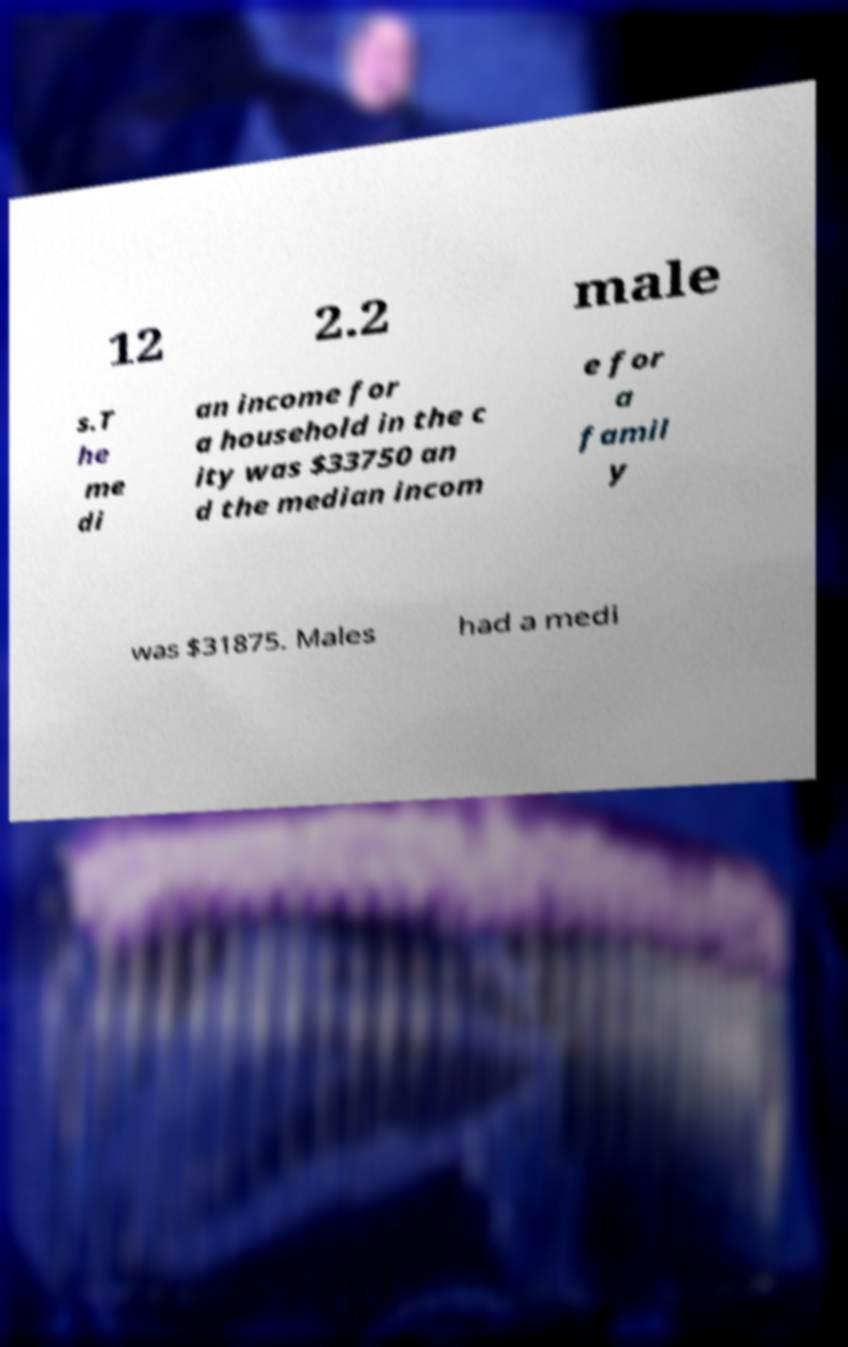Can you read and provide the text displayed in the image?This photo seems to have some interesting text. Can you extract and type it out for me? 12 2.2 male s.T he me di an income for a household in the c ity was $33750 an d the median incom e for a famil y was $31875. Males had a medi 